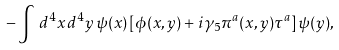<formula> <loc_0><loc_0><loc_500><loc_500>- \int \, d ^ { 4 } x \, d ^ { 4 } y \, \psi ( x ) \left [ \phi ( x , y ) + i \gamma _ { 5 } \pi ^ { a } ( x , y ) \tau ^ { a } \right ] \psi ( y ) ,</formula> 